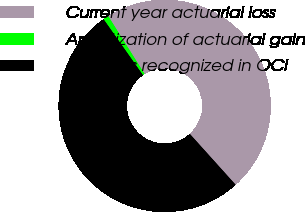<chart> <loc_0><loc_0><loc_500><loc_500><pie_chart><fcel>Current year actuarial loss<fcel>Amortization of actuarial gain<fcel>Amounts recognized in OCI<nl><fcel>47.26%<fcel>0.84%<fcel>51.9%<nl></chart> 